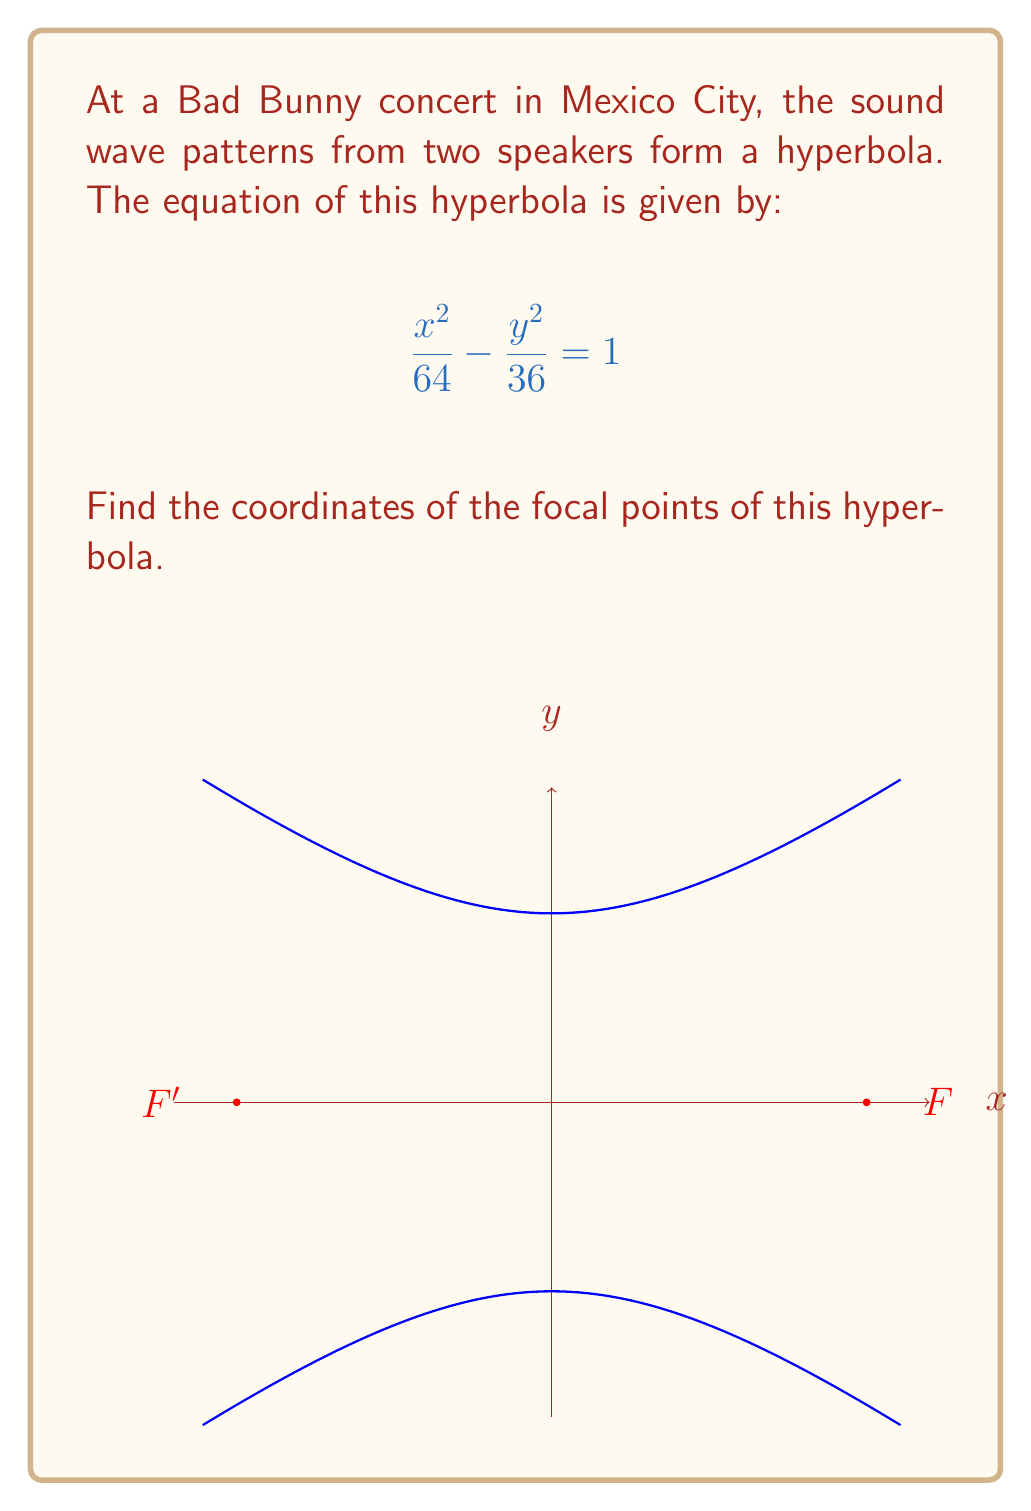Show me your answer to this math problem. Let's approach this step-by-step:

1) The general equation of a hyperbola centered at the origin is:

   $$\frac{x^2}{a^2} - \frac{y^2}{b^2} = 1$$

   where $a$ is the distance from the center to the vertex, and $b$ is the length of the conjugate axis.

2) Comparing our equation to the general form, we can see that:
   
   $a^2 = 64$, so $a = 8$
   $b^2 = 36$, so $b = 6$

3) For a hyperbola, the focal points lie on the transverse axis (in this case, the x-axis) at a distance $c$ from the center, where:

   $$c^2 = a^2 + b^2$$

4) Let's calculate $c$:

   $$c^2 = 8^2 + 6^2 = 64 + 36 = 100$$
   $$c = \sqrt{100} = 10$$

5) Therefore, the focal points are located at:

   $(c, 0)$ and $(-c, 0)$

   Which gives us $(10, 0)$ and $(-10, 0)$
Answer: $(10, 0)$ and $(-10, 0)$ 